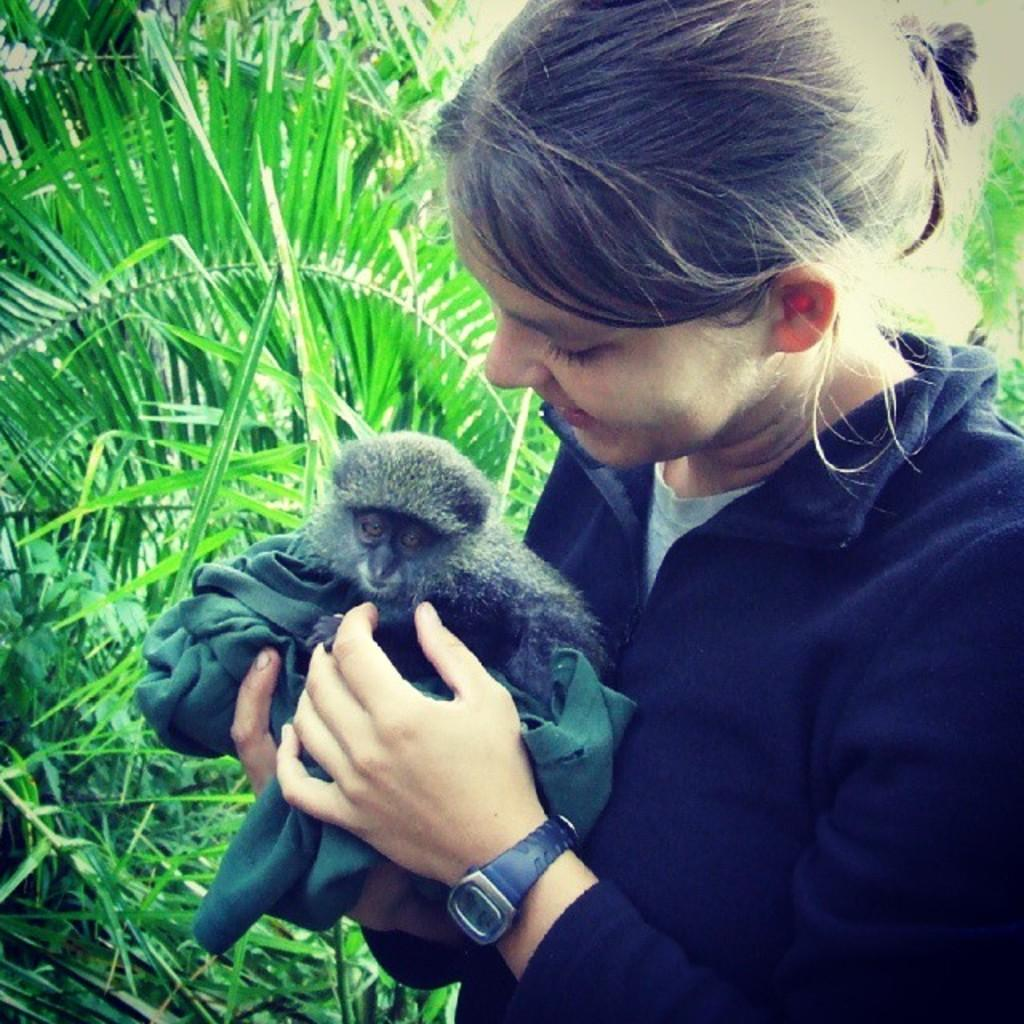Who is present in the image? There is a woman in the image. What is the woman holding? The woman is holding a monkey. What can be seen in the background of the image? There are trees and plants in the background of the image. What type of yam is being prepared by the army in the image? There is no army or yam present in the image; it features a woman holding a monkey with trees and plants in the background. 